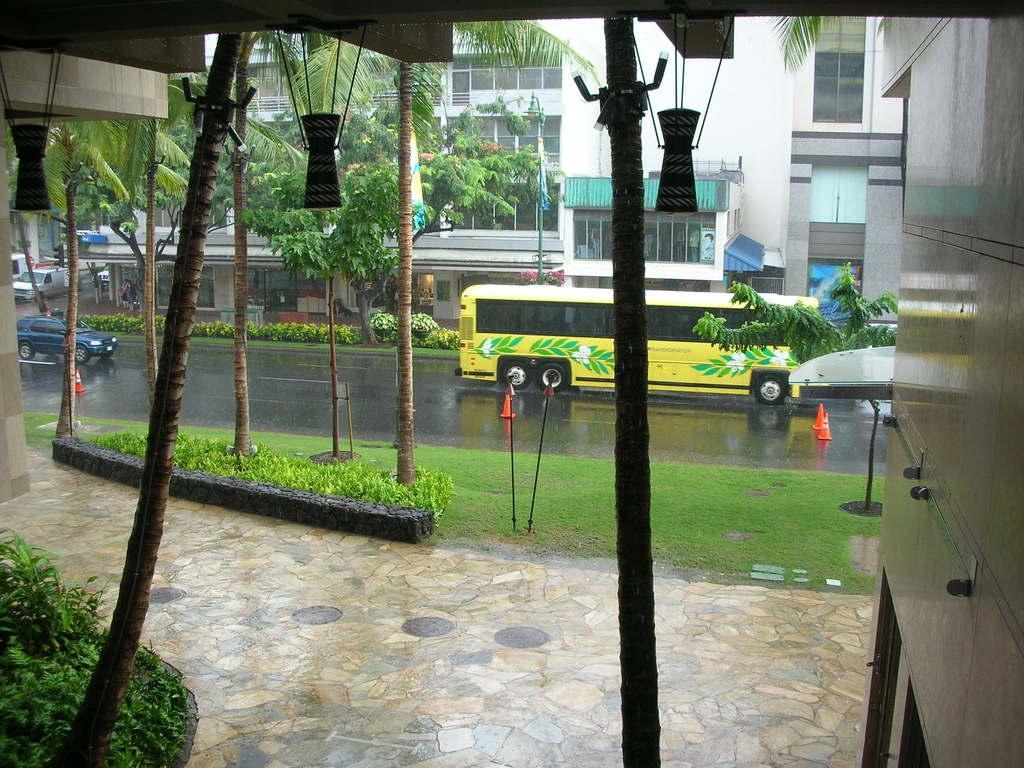Can you describe this image briefly? This picture is clicked outside the city. In the middle of the picture, we see a yellow bus and vehicles are moving on the road. Beside that, we see the traffic stoppers. Beside that, we see trees, grass, shrubs and poles. At the bottom, we see the floor, shrubs, stems of the trees and lanterns. On the right side, we see the cupboard. There are trees, buildings and poles in the background. 